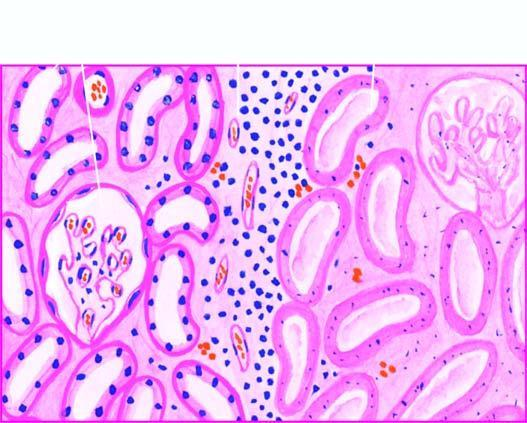re the outline of tubules still maintained?
Answer the question using a single word or phrase. Yes 